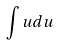Convert formula to latex. <formula><loc_0><loc_0><loc_500><loc_500>\int u d u</formula> 